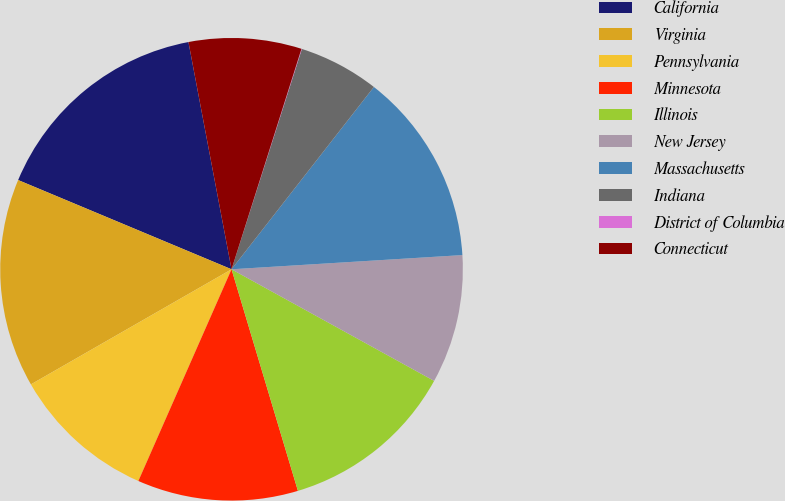<chart> <loc_0><loc_0><loc_500><loc_500><pie_chart><fcel>California<fcel>Virginia<fcel>Pennsylvania<fcel>Minnesota<fcel>Illinois<fcel>New Jersey<fcel>Massachusetts<fcel>Indiana<fcel>District of Columbia<fcel>Connecticut<nl><fcel>15.71%<fcel>14.59%<fcel>10.11%<fcel>11.23%<fcel>12.35%<fcel>8.99%<fcel>13.47%<fcel>5.63%<fcel>0.03%<fcel>7.87%<nl></chart> 